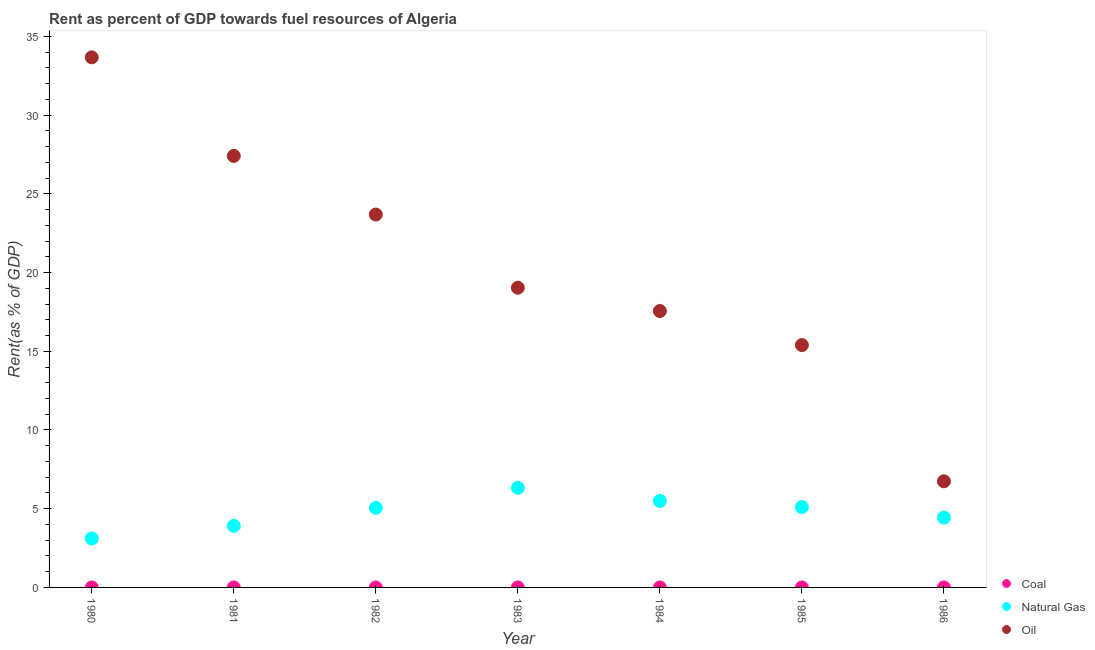What is the rent towards oil in 1983?
Offer a terse response. 19.04. Across all years, what is the maximum rent towards natural gas?
Your answer should be compact. 6.33. Across all years, what is the minimum rent towards oil?
Provide a succinct answer. 6.74. In which year was the rent towards oil minimum?
Provide a succinct answer. 1986. What is the total rent towards natural gas in the graph?
Provide a short and direct response. 33.44. What is the difference between the rent towards oil in 1980 and that in 1982?
Provide a short and direct response. 9.99. What is the difference between the rent towards oil in 1982 and the rent towards coal in 1980?
Provide a short and direct response. 23.69. What is the average rent towards oil per year?
Offer a very short reply. 20.5. In the year 1982, what is the difference between the rent towards oil and rent towards natural gas?
Your answer should be very brief. 18.63. In how many years, is the rent towards natural gas greater than 1 %?
Your response must be concise. 7. What is the ratio of the rent towards natural gas in 1980 to that in 1984?
Your answer should be compact. 0.57. Is the difference between the rent towards oil in 1980 and 1986 greater than the difference between the rent towards coal in 1980 and 1986?
Provide a succinct answer. Yes. What is the difference between the highest and the second highest rent towards coal?
Offer a terse response. 2.4731655570629037e-5. What is the difference between the highest and the lowest rent towards natural gas?
Offer a very short reply. 3.22. In how many years, is the rent towards coal greater than the average rent towards coal taken over all years?
Ensure brevity in your answer.  2. Is the sum of the rent towards coal in 1984 and 1986 greater than the maximum rent towards oil across all years?
Ensure brevity in your answer.  No. Is the rent towards oil strictly greater than the rent towards natural gas over the years?
Give a very brief answer. Yes. Is the rent towards oil strictly less than the rent towards natural gas over the years?
Your answer should be compact. No. How many years are there in the graph?
Offer a very short reply. 7. What is the difference between two consecutive major ticks on the Y-axis?
Provide a short and direct response. 5. How are the legend labels stacked?
Your answer should be very brief. Vertical. What is the title of the graph?
Your answer should be very brief. Rent as percent of GDP towards fuel resources of Algeria. Does "Female employers" appear as one of the legend labels in the graph?
Your answer should be very brief. No. What is the label or title of the Y-axis?
Make the answer very short. Rent(as % of GDP). What is the Rent(as % of GDP) in Coal in 1980?
Give a very brief answer. 0. What is the Rent(as % of GDP) in Natural Gas in 1980?
Make the answer very short. 3.11. What is the Rent(as % of GDP) of Oil in 1980?
Your answer should be very brief. 33.67. What is the Rent(as % of GDP) of Coal in 1981?
Your response must be concise. 0. What is the Rent(as % of GDP) in Natural Gas in 1981?
Provide a short and direct response. 3.91. What is the Rent(as % of GDP) of Oil in 1981?
Offer a very short reply. 27.41. What is the Rent(as % of GDP) of Coal in 1982?
Offer a terse response. 0. What is the Rent(as % of GDP) of Natural Gas in 1982?
Offer a terse response. 5.06. What is the Rent(as % of GDP) of Oil in 1982?
Your response must be concise. 23.69. What is the Rent(as % of GDP) of Coal in 1983?
Provide a succinct answer. 0. What is the Rent(as % of GDP) of Natural Gas in 1983?
Offer a terse response. 6.33. What is the Rent(as % of GDP) of Oil in 1983?
Provide a succinct answer. 19.04. What is the Rent(as % of GDP) in Coal in 1984?
Provide a short and direct response. 6.52912655872695e-5. What is the Rent(as % of GDP) of Natural Gas in 1984?
Your answer should be compact. 5.49. What is the Rent(as % of GDP) of Oil in 1984?
Provide a succinct answer. 17.56. What is the Rent(as % of GDP) in Coal in 1985?
Make the answer very short. 0. What is the Rent(as % of GDP) in Natural Gas in 1985?
Give a very brief answer. 5.1. What is the Rent(as % of GDP) of Oil in 1985?
Ensure brevity in your answer.  15.39. What is the Rent(as % of GDP) in Coal in 1986?
Offer a terse response. 1.11843058632871e-6. What is the Rent(as % of GDP) in Natural Gas in 1986?
Your response must be concise. 4.44. What is the Rent(as % of GDP) of Oil in 1986?
Ensure brevity in your answer.  6.74. Across all years, what is the maximum Rent(as % of GDP) in Coal?
Your answer should be very brief. 0. Across all years, what is the maximum Rent(as % of GDP) in Natural Gas?
Ensure brevity in your answer.  6.33. Across all years, what is the maximum Rent(as % of GDP) of Oil?
Provide a short and direct response. 33.67. Across all years, what is the minimum Rent(as % of GDP) of Coal?
Your answer should be compact. 1.11843058632871e-6. Across all years, what is the minimum Rent(as % of GDP) of Natural Gas?
Your answer should be very brief. 3.11. Across all years, what is the minimum Rent(as % of GDP) of Oil?
Offer a very short reply. 6.74. What is the total Rent(as % of GDP) in Coal in the graph?
Provide a short and direct response. 0. What is the total Rent(as % of GDP) in Natural Gas in the graph?
Ensure brevity in your answer.  33.44. What is the total Rent(as % of GDP) of Oil in the graph?
Your response must be concise. 143.5. What is the difference between the Rent(as % of GDP) of Coal in 1980 and that in 1981?
Your answer should be very brief. -0. What is the difference between the Rent(as % of GDP) of Natural Gas in 1980 and that in 1981?
Keep it short and to the point. -0.8. What is the difference between the Rent(as % of GDP) of Oil in 1980 and that in 1981?
Provide a succinct answer. 6.26. What is the difference between the Rent(as % of GDP) of Coal in 1980 and that in 1982?
Make the answer very short. -0. What is the difference between the Rent(as % of GDP) in Natural Gas in 1980 and that in 1982?
Your answer should be compact. -1.95. What is the difference between the Rent(as % of GDP) of Oil in 1980 and that in 1982?
Make the answer very short. 9.99. What is the difference between the Rent(as % of GDP) in Coal in 1980 and that in 1983?
Offer a very short reply. 0. What is the difference between the Rent(as % of GDP) of Natural Gas in 1980 and that in 1983?
Your answer should be compact. -3.22. What is the difference between the Rent(as % of GDP) of Oil in 1980 and that in 1983?
Make the answer very short. 14.64. What is the difference between the Rent(as % of GDP) of Coal in 1980 and that in 1984?
Provide a succinct answer. 0. What is the difference between the Rent(as % of GDP) of Natural Gas in 1980 and that in 1984?
Ensure brevity in your answer.  -2.38. What is the difference between the Rent(as % of GDP) of Oil in 1980 and that in 1984?
Give a very brief answer. 16.12. What is the difference between the Rent(as % of GDP) in Natural Gas in 1980 and that in 1985?
Keep it short and to the point. -1.99. What is the difference between the Rent(as % of GDP) in Oil in 1980 and that in 1985?
Keep it short and to the point. 18.28. What is the difference between the Rent(as % of GDP) in Natural Gas in 1980 and that in 1986?
Ensure brevity in your answer.  -1.33. What is the difference between the Rent(as % of GDP) in Oil in 1980 and that in 1986?
Your answer should be compact. 26.93. What is the difference between the Rent(as % of GDP) in Natural Gas in 1981 and that in 1982?
Offer a terse response. -1.15. What is the difference between the Rent(as % of GDP) of Oil in 1981 and that in 1982?
Make the answer very short. 3.73. What is the difference between the Rent(as % of GDP) of Natural Gas in 1981 and that in 1983?
Give a very brief answer. -2.42. What is the difference between the Rent(as % of GDP) in Oil in 1981 and that in 1983?
Your response must be concise. 8.37. What is the difference between the Rent(as % of GDP) in Natural Gas in 1981 and that in 1984?
Your answer should be very brief. -1.58. What is the difference between the Rent(as % of GDP) of Oil in 1981 and that in 1984?
Give a very brief answer. 9.85. What is the difference between the Rent(as % of GDP) in Coal in 1981 and that in 1985?
Give a very brief answer. 0. What is the difference between the Rent(as % of GDP) in Natural Gas in 1981 and that in 1985?
Provide a succinct answer. -1.19. What is the difference between the Rent(as % of GDP) in Oil in 1981 and that in 1985?
Your answer should be compact. 12.02. What is the difference between the Rent(as % of GDP) in Natural Gas in 1981 and that in 1986?
Your answer should be very brief. -0.53. What is the difference between the Rent(as % of GDP) of Oil in 1981 and that in 1986?
Ensure brevity in your answer.  20.67. What is the difference between the Rent(as % of GDP) in Coal in 1982 and that in 1983?
Offer a terse response. 0. What is the difference between the Rent(as % of GDP) in Natural Gas in 1982 and that in 1983?
Your answer should be compact. -1.27. What is the difference between the Rent(as % of GDP) of Oil in 1982 and that in 1983?
Keep it short and to the point. 4.65. What is the difference between the Rent(as % of GDP) in Coal in 1982 and that in 1984?
Provide a short and direct response. 0. What is the difference between the Rent(as % of GDP) of Natural Gas in 1982 and that in 1984?
Your response must be concise. -0.44. What is the difference between the Rent(as % of GDP) in Oil in 1982 and that in 1984?
Your answer should be compact. 6.13. What is the difference between the Rent(as % of GDP) of Natural Gas in 1982 and that in 1985?
Your response must be concise. -0.05. What is the difference between the Rent(as % of GDP) of Oil in 1982 and that in 1985?
Provide a short and direct response. 8.29. What is the difference between the Rent(as % of GDP) in Natural Gas in 1982 and that in 1986?
Your answer should be very brief. 0.62. What is the difference between the Rent(as % of GDP) in Oil in 1982 and that in 1986?
Offer a terse response. 16.95. What is the difference between the Rent(as % of GDP) of Natural Gas in 1983 and that in 1984?
Ensure brevity in your answer.  0.83. What is the difference between the Rent(as % of GDP) in Oil in 1983 and that in 1984?
Ensure brevity in your answer.  1.48. What is the difference between the Rent(as % of GDP) in Coal in 1983 and that in 1985?
Keep it short and to the point. 0. What is the difference between the Rent(as % of GDP) of Natural Gas in 1983 and that in 1985?
Your response must be concise. 1.22. What is the difference between the Rent(as % of GDP) in Oil in 1983 and that in 1985?
Your response must be concise. 3.64. What is the difference between the Rent(as % of GDP) in Natural Gas in 1983 and that in 1986?
Your answer should be compact. 1.89. What is the difference between the Rent(as % of GDP) in Oil in 1983 and that in 1986?
Your answer should be compact. 12.3. What is the difference between the Rent(as % of GDP) of Natural Gas in 1984 and that in 1985?
Offer a terse response. 0.39. What is the difference between the Rent(as % of GDP) of Oil in 1984 and that in 1985?
Give a very brief answer. 2.16. What is the difference between the Rent(as % of GDP) in Coal in 1984 and that in 1986?
Ensure brevity in your answer.  0. What is the difference between the Rent(as % of GDP) of Natural Gas in 1984 and that in 1986?
Make the answer very short. 1.06. What is the difference between the Rent(as % of GDP) in Oil in 1984 and that in 1986?
Give a very brief answer. 10.82. What is the difference between the Rent(as % of GDP) in Coal in 1985 and that in 1986?
Your answer should be very brief. 0. What is the difference between the Rent(as % of GDP) in Natural Gas in 1985 and that in 1986?
Give a very brief answer. 0.67. What is the difference between the Rent(as % of GDP) in Oil in 1985 and that in 1986?
Your response must be concise. 8.65. What is the difference between the Rent(as % of GDP) of Coal in 1980 and the Rent(as % of GDP) of Natural Gas in 1981?
Your answer should be compact. -3.91. What is the difference between the Rent(as % of GDP) of Coal in 1980 and the Rent(as % of GDP) of Oil in 1981?
Offer a very short reply. -27.41. What is the difference between the Rent(as % of GDP) in Natural Gas in 1980 and the Rent(as % of GDP) in Oil in 1981?
Your response must be concise. -24.3. What is the difference between the Rent(as % of GDP) of Coal in 1980 and the Rent(as % of GDP) of Natural Gas in 1982?
Your response must be concise. -5.06. What is the difference between the Rent(as % of GDP) in Coal in 1980 and the Rent(as % of GDP) in Oil in 1982?
Your answer should be compact. -23.69. What is the difference between the Rent(as % of GDP) of Natural Gas in 1980 and the Rent(as % of GDP) of Oil in 1982?
Give a very brief answer. -20.58. What is the difference between the Rent(as % of GDP) in Coal in 1980 and the Rent(as % of GDP) in Natural Gas in 1983?
Make the answer very short. -6.33. What is the difference between the Rent(as % of GDP) of Coal in 1980 and the Rent(as % of GDP) of Oil in 1983?
Your answer should be very brief. -19.04. What is the difference between the Rent(as % of GDP) in Natural Gas in 1980 and the Rent(as % of GDP) in Oil in 1983?
Provide a short and direct response. -15.93. What is the difference between the Rent(as % of GDP) of Coal in 1980 and the Rent(as % of GDP) of Natural Gas in 1984?
Keep it short and to the point. -5.49. What is the difference between the Rent(as % of GDP) in Coal in 1980 and the Rent(as % of GDP) in Oil in 1984?
Ensure brevity in your answer.  -17.56. What is the difference between the Rent(as % of GDP) of Natural Gas in 1980 and the Rent(as % of GDP) of Oil in 1984?
Your answer should be very brief. -14.45. What is the difference between the Rent(as % of GDP) of Coal in 1980 and the Rent(as % of GDP) of Natural Gas in 1985?
Offer a very short reply. -5.1. What is the difference between the Rent(as % of GDP) in Coal in 1980 and the Rent(as % of GDP) in Oil in 1985?
Make the answer very short. -15.39. What is the difference between the Rent(as % of GDP) of Natural Gas in 1980 and the Rent(as % of GDP) of Oil in 1985?
Provide a succinct answer. -12.28. What is the difference between the Rent(as % of GDP) in Coal in 1980 and the Rent(as % of GDP) in Natural Gas in 1986?
Provide a succinct answer. -4.44. What is the difference between the Rent(as % of GDP) of Coal in 1980 and the Rent(as % of GDP) of Oil in 1986?
Give a very brief answer. -6.74. What is the difference between the Rent(as % of GDP) in Natural Gas in 1980 and the Rent(as % of GDP) in Oil in 1986?
Make the answer very short. -3.63. What is the difference between the Rent(as % of GDP) of Coal in 1981 and the Rent(as % of GDP) of Natural Gas in 1982?
Offer a terse response. -5.06. What is the difference between the Rent(as % of GDP) in Coal in 1981 and the Rent(as % of GDP) in Oil in 1982?
Make the answer very short. -23.69. What is the difference between the Rent(as % of GDP) in Natural Gas in 1981 and the Rent(as % of GDP) in Oil in 1982?
Provide a short and direct response. -19.77. What is the difference between the Rent(as % of GDP) of Coal in 1981 and the Rent(as % of GDP) of Natural Gas in 1983?
Your answer should be very brief. -6.33. What is the difference between the Rent(as % of GDP) of Coal in 1981 and the Rent(as % of GDP) of Oil in 1983?
Your response must be concise. -19.04. What is the difference between the Rent(as % of GDP) of Natural Gas in 1981 and the Rent(as % of GDP) of Oil in 1983?
Provide a succinct answer. -15.13. What is the difference between the Rent(as % of GDP) in Coal in 1981 and the Rent(as % of GDP) in Natural Gas in 1984?
Offer a very short reply. -5.49. What is the difference between the Rent(as % of GDP) of Coal in 1981 and the Rent(as % of GDP) of Oil in 1984?
Give a very brief answer. -17.56. What is the difference between the Rent(as % of GDP) of Natural Gas in 1981 and the Rent(as % of GDP) of Oil in 1984?
Your answer should be compact. -13.65. What is the difference between the Rent(as % of GDP) of Coal in 1981 and the Rent(as % of GDP) of Natural Gas in 1985?
Your answer should be very brief. -5.1. What is the difference between the Rent(as % of GDP) of Coal in 1981 and the Rent(as % of GDP) of Oil in 1985?
Keep it short and to the point. -15.39. What is the difference between the Rent(as % of GDP) of Natural Gas in 1981 and the Rent(as % of GDP) of Oil in 1985?
Ensure brevity in your answer.  -11.48. What is the difference between the Rent(as % of GDP) of Coal in 1981 and the Rent(as % of GDP) of Natural Gas in 1986?
Offer a terse response. -4.44. What is the difference between the Rent(as % of GDP) in Coal in 1981 and the Rent(as % of GDP) in Oil in 1986?
Make the answer very short. -6.74. What is the difference between the Rent(as % of GDP) of Natural Gas in 1981 and the Rent(as % of GDP) of Oil in 1986?
Your response must be concise. -2.83. What is the difference between the Rent(as % of GDP) in Coal in 1982 and the Rent(as % of GDP) in Natural Gas in 1983?
Keep it short and to the point. -6.33. What is the difference between the Rent(as % of GDP) in Coal in 1982 and the Rent(as % of GDP) in Oil in 1983?
Your answer should be compact. -19.04. What is the difference between the Rent(as % of GDP) of Natural Gas in 1982 and the Rent(as % of GDP) of Oil in 1983?
Provide a short and direct response. -13.98. What is the difference between the Rent(as % of GDP) in Coal in 1982 and the Rent(as % of GDP) in Natural Gas in 1984?
Provide a short and direct response. -5.49. What is the difference between the Rent(as % of GDP) in Coal in 1982 and the Rent(as % of GDP) in Oil in 1984?
Offer a very short reply. -17.56. What is the difference between the Rent(as % of GDP) in Coal in 1982 and the Rent(as % of GDP) in Natural Gas in 1985?
Keep it short and to the point. -5.1. What is the difference between the Rent(as % of GDP) of Coal in 1982 and the Rent(as % of GDP) of Oil in 1985?
Offer a very short reply. -15.39. What is the difference between the Rent(as % of GDP) in Natural Gas in 1982 and the Rent(as % of GDP) in Oil in 1985?
Offer a terse response. -10.34. What is the difference between the Rent(as % of GDP) of Coal in 1982 and the Rent(as % of GDP) of Natural Gas in 1986?
Make the answer very short. -4.44. What is the difference between the Rent(as % of GDP) of Coal in 1982 and the Rent(as % of GDP) of Oil in 1986?
Your response must be concise. -6.74. What is the difference between the Rent(as % of GDP) in Natural Gas in 1982 and the Rent(as % of GDP) in Oil in 1986?
Your answer should be very brief. -1.68. What is the difference between the Rent(as % of GDP) in Coal in 1983 and the Rent(as % of GDP) in Natural Gas in 1984?
Keep it short and to the point. -5.49. What is the difference between the Rent(as % of GDP) of Coal in 1983 and the Rent(as % of GDP) of Oil in 1984?
Provide a succinct answer. -17.56. What is the difference between the Rent(as % of GDP) in Natural Gas in 1983 and the Rent(as % of GDP) in Oil in 1984?
Make the answer very short. -11.23. What is the difference between the Rent(as % of GDP) of Coal in 1983 and the Rent(as % of GDP) of Natural Gas in 1985?
Provide a succinct answer. -5.1. What is the difference between the Rent(as % of GDP) of Coal in 1983 and the Rent(as % of GDP) of Oil in 1985?
Your response must be concise. -15.39. What is the difference between the Rent(as % of GDP) of Natural Gas in 1983 and the Rent(as % of GDP) of Oil in 1985?
Offer a very short reply. -9.07. What is the difference between the Rent(as % of GDP) of Coal in 1983 and the Rent(as % of GDP) of Natural Gas in 1986?
Make the answer very short. -4.44. What is the difference between the Rent(as % of GDP) of Coal in 1983 and the Rent(as % of GDP) of Oil in 1986?
Provide a short and direct response. -6.74. What is the difference between the Rent(as % of GDP) in Natural Gas in 1983 and the Rent(as % of GDP) in Oil in 1986?
Keep it short and to the point. -0.41. What is the difference between the Rent(as % of GDP) in Coal in 1984 and the Rent(as % of GDP) in Natural Gas in 1985?
Offer a very short reply. -5.1. What is the difference between the Rent(as % of GDP) in Coal in 1984 and the Rent(as % of GDP) in Oil in 1985?
Give a very brief answer. -15.39. What is the difference between the Rent(as % of GDP) in Natural Gas in 1984 and the Rent(as % of GDP) in Oil in 1985?
Your answer should be very brief. -9.9. What is the difference between the Rent(as % of GDP) of Coal in 1984 and the Rent(as % of GDP) of Natural Gas in 1986?
Offer a terse response. -4.44. What is the difference between the Rent(as % of GDP) in Coal in 1984 and the Rent(as % of GDP) in Oil in 1986?
Ensure brevity in your answer.  -6.74. What is the difference between the Rent(as % of GDP) of Natural Gas in 1984 and the Rent(as % of GDP) of Oil in 1986?
Ensure brevity in your answer.  -1.25. What is the difference between the Rent(as % of GDP) in Coal in 1985 and the Rent(as % of GDP) in Natural Gas in 1986?
Keep it short and to the point. -4.44. What is the difference between the Rent(as % of GDP) in Coal in 1985 and the Rent(as % of GDP) in Oil in 1986?
Make the answer very short. -6.74. What is the difference between the Rent(as % of GDP) of Natural Gas in 1985 and the Rent(as % of GDP) of Oil in 1986?
Give a very brief answer. -1.64. What is the average Rent(as % of GDP) in Natural Gas per year?
Offer a terse response. 4.78. What is the average Rent(as % of GDP) in Oil per year?
Provide a succinct answer. 20.5. In the year 1980, what is the difference between the Rent(as % of GDP) in Coal and Rent(as % of GDP) in Natural Gas?
Keep it short and to the point. -3.11. In the year 1980, what is the difference between the Rent(as % of GDP) in Coal and Rent(as % of GDP) in Oil?
Your answer should be compact. -33.67. In the year 1980, what is the difference between the Rent(as % of GDP) of Natural Gas and Rent(as % of GDP) of Oil?
Ensure brevity in your answer.  -30.56. In the year 1981, what is the difference between the Rent(as % of GDP) of Coal and Rent(as % of GDP) of Natural Gas?
Keep it short and to the point. -3.91. In the year 1981, what is the difference between the Rent(as % of GDP) of Coal and Rent(as % of GDP) of Oil?
Make the answer very short. -27.41. In the year 1981, what is the difference between the Rent(as % of GDP) in Natural Gas and Rent(as % of GDP) in Oil?
Ensure brevity in your answer.  -23.5. In the year 1982, what is the difference between the Rent(as % of GDP) of Coal and Rent(as % of GDP) of Natural Gas?
Your answer should be compact. -5.06. In the year 1982, what is the difference between the Rent(as % of GDP) of Coal and Rent(as % of GDP) of Oil?
Keep it short and to the point. -23.69. In the year 1982, what is the difference between the Rent(as % of GDP) of Natural Gas and Rent(as % of GDP) of Oil?
Offer a terse response. -18.63. In the year 1983, what is the difference between the Rent(as % of GDP) of Coal and Rent(as % of GDP) of Natural Gas?
Offer a terse response. -6.33. In the year 1983, what is the difference between the Rent(as % of GDP) in Coal and Rent(as % of GDP) in Oil?
Offer a very short reply. -19.04. In the year 1983, what is the difference between the Rent(as % of GDP) in Natural Gas and Rent(as % of GDP) in Oil?
Ensure brevity in your answer.  -12.71. In the year 1984, what is the difference between the Rent(as % of GDP) of Coal and Rent(as % of GDP) of Natural Gas?
Ensure brevity in your answer.  -5.49. In the year 1984, what is the difference between the Rent(as % of GDP) in Coal and Rent(as % of GDP) in Oil?
Make the answer very short. -17.56. In the year 1984, what is the difference between the Rent(as % of GDP) in Natural Gas and Rent(as % of GDP) in Oil?
Keep it short and to the point. -12.06. In the year 1985, what is the difference between the Rent(as % of GDP) in Coal and Rent(as % of GDP) in Natural Gas?
Give a very brief answer. -5.1. In the year 1985, what is the difference between the Rent(as % of GDP) of Coal and Rent(as % of GDP) of Oil?
Provide a short and direct response. -15.39. In the year 1985, what is the difference between the Rent(as % of GDP) in Natural Gas and Rent(as % of GDP) in Oil?
Your answer should be compact. -10.29. In the year 1986, what is the difference between the Rent(as % of GDP) in Coal and Rent(as % of GDP) in Natural Gas?
Ensure brevity in your answer.  -4.44. In the year 1986, what is the difference between the Rent(as % of GDP) of Coal and Rent(as % of GDP) of Oil?
Your answer should be compact. -6.74. In the year 1986, what is the difference between the Rent(as % of GDP) in Natural Gas and Rent(as % of GDP) in Oil?
Offer a terse response. -2.3. What is the ratio of the Rent(as % of GDP) in Coal in 1980 to that in 1981?
Ensure brevity in your answer.  0.45. What is the ratio of the Rent(as % of GDP) in Natural Gas in 1980 to that in 1981?
Your response must be concise. 0.8. What is the ratio of the Rent(as % of GDP) in Oil in 1980 to that in 1981?
Your answer should be very brief. 1.23. What is the ratio of the Rent(as % of GDP) of Coal in 1980 to that in 1982?
Offer a very short reply. 0.42. What is the ratio of the Rent(as % of GDP) in Natural Gas in 1980 to that in 1982?
Your answer should be very brief. 0.61. What is the ratio of the Rent(as % of GDP) of Oil in 1980 to that in 1982?
Keep it short and to the point. 1.42. What is the ratio of the Rent(as % of GDP) of Coal in 1980 to that in 1983?
Offer a terse response. 1.18. What is the ratio of the Rent(as % of GDP) of Natural Gas in 1980 to that in 1983?
Your answer should be very brief. 0.49. What is the ratio of the Rent(as % of GDP) of Oil in 1980 to that in 1983?
Your response must be concise. 1.77. What is the ratio of the Rent(as % of GDP) in Coal in 1980 to that in 1984?
Make the answer very short. 2.59. What is the ratio of the Rent(as % of GDP) in Natural Gas in 1980 to that in 1984?
Your answer should be very brief. 0.57. What is the ratio of the Rent(as % of GDP) of Oil in 1980 to that in 1984?
Keep it short and to the point. 1.92. What is the ratio of the Rent(as % of GDP) of Coal in 1980 to that in 1985?
Provide a short and direct response. 1.57. What is the ratio of the Rent(as % of GDP) of Natural Gas in 1980 to that in 1985?
Your answer should be very brief. 0.61. What is the ratio of the Rent(as % of GDP) of Oil in 1980 to that in 1985?
Provide a succinct answer. 2.19. What is the ratio of the Rent(as % of GDP) of Coal in 1980 to that in 1986?
Your response must be concise. 151.47. What is the ratio of the Rent(as % of GDP) in Natural Gas in 1980 to that in 1986?
Provide a succinct answer. 0.7. What is the ratio of the Rent(as % of GDP) in Oil in 1980 to that in 1986?
Make the answer very short. 5. What is the ratio of the Rent(as % of GDP) in Coal in 1981 to that in 1982?
Offer a terse response. 0.94. What is the ratio of the Rent(as % of GDP) of Natural Gas in 1981 to that in 1982?
Make the answer very short. 0.77. What is the ratio of the Rent(as % of GDP) in Oil in 1981 to that in 1982?
Give a very brief answer. 1.16. What is the ratio of the Rent(as % of GDP) in Coal in 1981 to that in 1983?
Keep it short and to the point. 2.63. What is the ratio of the Rent(as % of GDP) of Natural Gas in 1981 to that in 1983?
Provide a short and direct response. 0.62. What is the ratio of the Rent(as % of GDP) of Oil in 1981 to that in 1983?
Offer a very short reply. 1.44. What is the ratio of the Rent(as % of GDP) of Coal in 1981 to that in 1984?
Make the answer very short. 5.77. What is the ratio of the Rent(as % of GDP) of Natural Gas in 1981 to that in 1984?
Offer a very short reply. 0.71. What is the ratio of the Rent(as % of GDP) of Oil in 1981 to that in 1984?
Your answer should be compact. 1.56. What is the ratio of the Rent(as % of GDP) of Coal in 1981 to that in 1985?
Provide a short and direct response. 3.49. What is the ratio of the Rent(as % of GDP) of Natural Gas in 1981 to that in 1985?
Provide a succinct answer. 0.77. What is the ratio of the Rent(as % of GDP) of Oil in 1981 to that in 1985?
Your answer should be compact. 1.78. What is the ratio of the Rent(as % of GDP) of Coal in 1981 to that in 1986?
Make the answer very short. 337.07. What is the ratio of the Rent(as % of GDP) in Natural Gas in 1981 to that in 1986?
Offer a very short reply. 0.88. What is the ratio of the Rent(as % of GDP) in Oil in 1981 to that in 1986?
Ensure brevity in your answer.  4.07. What is the ratio of the Rent(as % of GDP) in Coal in 1982 to that in 1983?
Give a very brief answer. 2.81. What is the ratio of the Rent(as % of GDP) of Natural Gas in 1982 to that in 1983?
Provide a short and direct response. 0.8. What is the ratio of the Rent(as % of GDP) of Oil in 1982 to that in 1983?
Offer a terse response. 1.24. What is the ratio of the Rent(as % of GDP) in Coal in 1982 to that in 1984?
Offer a terse response. 6.15. What is the ratio of the Rent(as % of GDP) in Natural Gas in 1982 to that in 1984?
Give a very brief answer. 0.92. What is the ratio of the Rent(as % of GDP) of Oil in 1982 to that in 1984?
Your response must be concise. 1.35. What is the ratio of the Rent(as % of GDP) of Coal in 1982 to that in 1985?
Offer a very short reply. 3.72. What is the ratio of the Rent(as % of GDP) of Natural Gas in 1982 to that in 1985?
Your answer should be compact. 0.99. What is the ratio of the Rent(as % of GDP) in Oil in 1982 to that in 1985?
Provide a succinct answer. 1.54. What is the ratio of the Rent(as % of GDP) in Coal in 1982 to that in 1986?
Give a very brief answer. 359.19. What is the ratio of the Rent(as % of GDP) of Natural Gas in 1982 to that in 1986?
Provide a succinct answer. 1.14. What is the ratio of the Rent(as % of GDP) in Oil in 1982 to that in 1986?
Provide a short and direct response. 3.51. What is the ratio of the Rent(as % of GDP) of Coal in 1983 to that in 1984?
Your answer should be very brief. 2.19. What is the ratio of the Rent(as % of GDP) in Natural Gas in 1983 to that in 1984?
Your answer should be compact. 1.15. What is the ratio of the Rent(as % of GDP) of Oil in 1983 to that in 1984?
Offer a very short reply. 1.08. What is the ratio of the Rent(as % of GDP) in Coal in 1983 to that in 1985?
Your answer should be very brief. 1.32. What is the ratio of the Rent(as % of GDP) in Natural Gas in 1983 to that in 1985?
Make the answer very short. 1.24. What is the ratio of the Rent(as % of GDP) in Oil in 1983 to that in 1985?
Provide a short and direct response. 1.24. What is the ratio of the Rent(as % of GDP) in Coal in 1983 to that in 1986?
Keep it short and to the point. 127.94. What is the ratio of the Rent(as % of GDP) in Natural Gas in 1983 to that in 1986?
Your response must be concise. 1.43. What is the ratio of the Rent(as % of GDP) of Oil in 1983 to that in 1986?
Offer a terse response. 2.82. What is the ratio of the Rent(as % of GDP) of Coal in 1984 to that in 1985?
Offer a terse response. 0.6. What is the ratio of the Rent(as % of GDP) of Natural Gas in 1984 to that in 1985?
Give a very brief answer. 1.08. What is the ratio of the Rent(as % of GDP) of Oil in 1984 to that in 1985?
Your answer should be compact. 1.14. What is the ratio of the Rent(as % of GDP) in Coal in 1984 to that in 1986?
Your answer should be compact. 58.38. What is the ratio of the Rent(as % of GDP) of Natural Gas in 1984 to that in 1986?
Your answer should be compact. 1.24. What is the ratio of the Rent(as % of GDP) in Oil in 1984 to that in 1986?
Provide a succinct answer. 2.6. What is the ratio of the Rent(as % of GDP) in Coal in 1985 to that in 1986?
Offer a terse response. 96.59. What is the ratio of the Rent(as % of GDP) in Natural Gas in 1985 to that in 1986?
Keep it short and to the point. 1.15. What is the ratio of the Rent(as % of GDP) of Oil in 1985 to that in 1986?
Provide a short and direct response. 2.28. What is the difference between the highest and the second highest Rent(as % of GDP) in Natural Gas?
Your answer should be very brief. 0.83. What is the difference between the highest and the second highest Rent(as % of GDP) in Oil?
Provide a short and direct response. 6.26. What is the difference between the highest and the lowest Rent(as % of GDP) in Coal?
Give a very brief answer. 0. What is the difference between the highest and the lowest Rent(as % of GDP) in Natural Gas?
Your response must be concise. 3.22. What is the difference between the highest and the lowest Rent(as % of GDP) in Oil?
Provide a short and direct response. 26.93. 